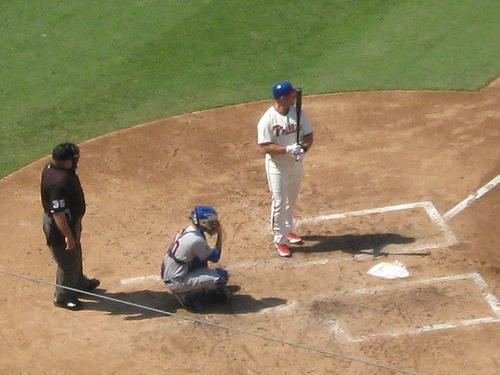How many men are there?
Give a very brief answer. 3. 